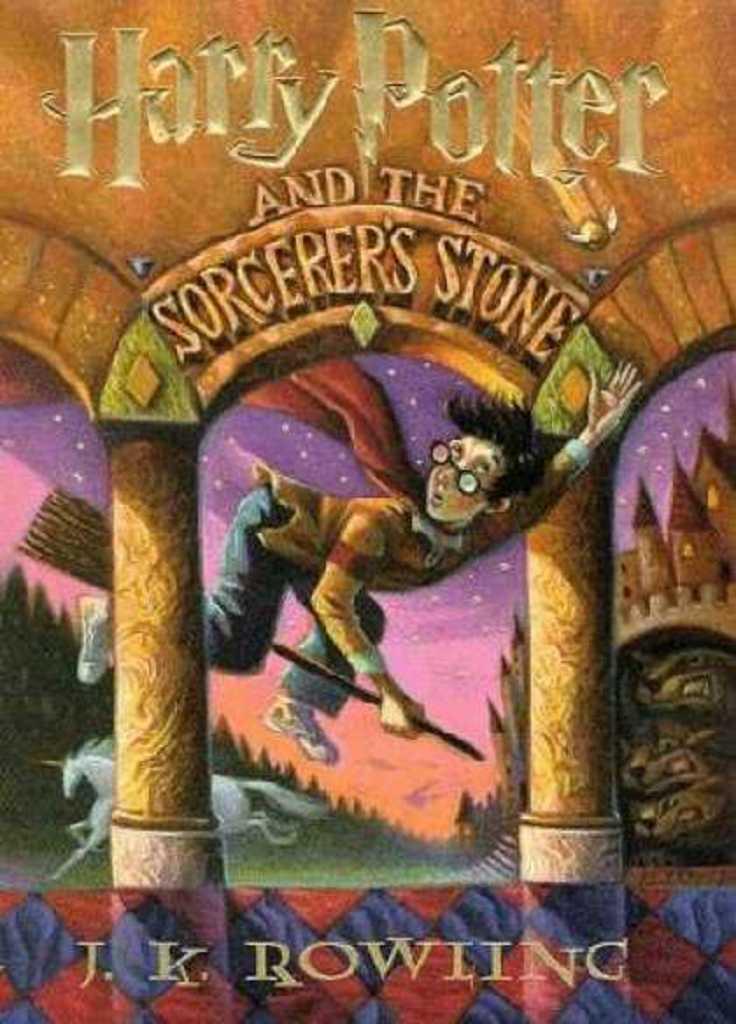Harry potter and the sorcerers stone is a book by?
Your response must be concise. J.k. rowling. 